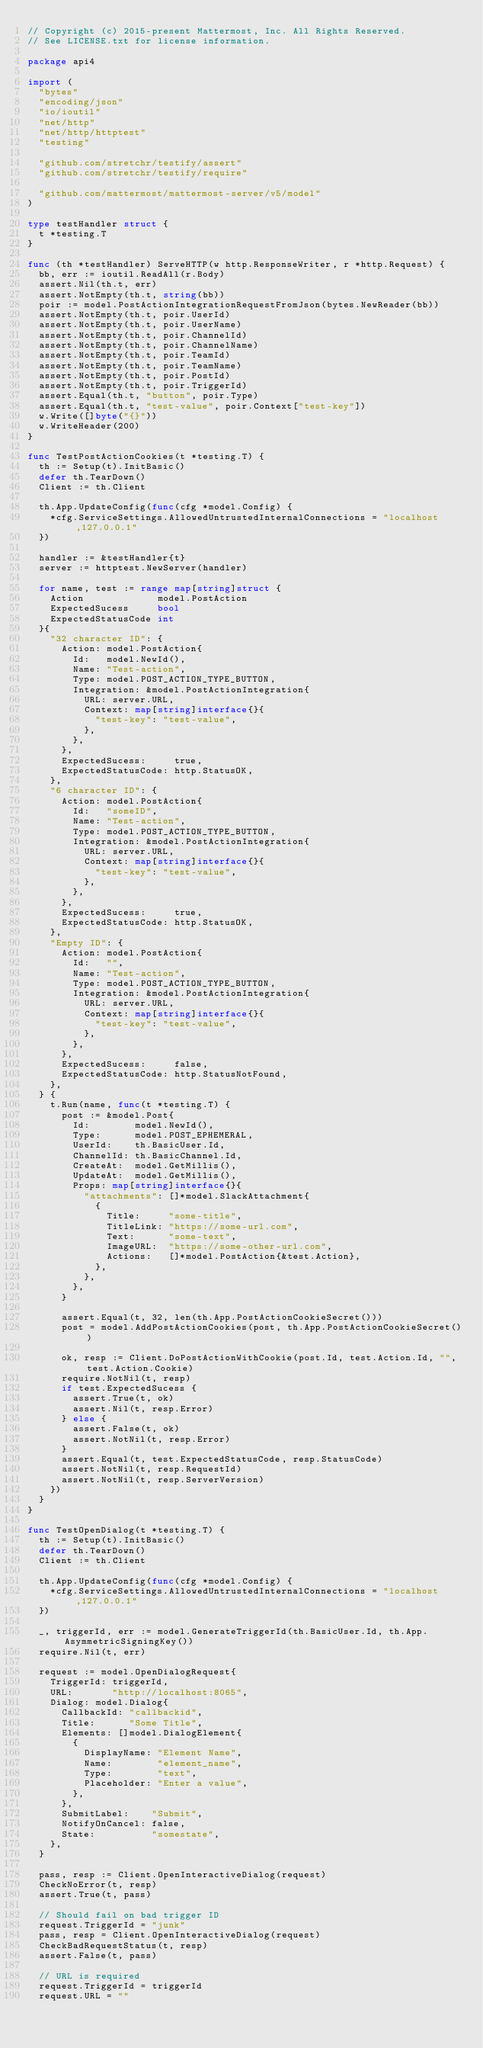Convert code to text. <code><loc_0><loc_0><loc_500><loc_500><_Go_>// Copyright (c) 2015-present Mattermost, Inc. All Rights Reserved.
// See LICENSE.txt for license information.

package api4

import (
	"bytes"
	"encoding/json"
	"io/ioutil"
	"net/http"
	"net/http/httptest"
	"testing"

	"github.com/stretchr/testify/assert"
	"github.com/stretchr/testify/require"

	"github.com/mattermost/mattermost-server/v5/model"
)

type testHandler struct {
	t *testing.T
}

func (th *testHandler) ServeHTTP(w http.ResponseWriter, r *http.Request) {
	bb, err := ioutil.ReadAll(r.Body)
	assert.Nil(th.t, err)
	assert.NotEmpty(th.t, string(bb))
	poir := model.PostActionIntegrationRequestFromJson(bytes.NewReader(bb))
	assert.NotEmpty(th.t, poir.UserId)
	assert.NotEmpty(th.t, poir.UserName)
	assert.NotEmpty(th.t, poir.ChannelId)
	assert.NotEmpty(th.t, poir.ChannelName)
	assert.NotEmpty(th.t, poir.TeamId)
	assert.NotEmpty(th.t, poir.TeamName)
	assert.NotEmpty(th.t, poir.PostId)
	assert.NotEmpty(th.t, poir.TriggerId)
	assert.Equal(th.t, "button", poir.Type)
	assert.Equal(th.t, "test-value", poir.Context["test-key"])
	w.Write([]byte("{}"))
	w.WriteHeader(200)
}

func TestPostActionCookies(t *testing.T) {
	th := Setup(t).InitBasic()
	defer th.TearDown()
	Client := th.Client

	th.App.UpdateConfig(func(cfg *model.Config) {
		*cfg.ServiceSettings.AllowedUntrustedInternalConnections = "localhost,127.0.0.1"
	})

	handler := &testHandler{t}
	server := httptest.NewServer(handler)

	for name, test := range map[string]struct {
		Action             model.PostAction
		ExpectedSucess     bool
		ExpectedStatusCode int
	}{
		"32 character ID": {
			Action: model.PostAction{
				Id:   model.NewId(),
				Name: "Test-action",
				Type: model.POST_ACTION_TYPE_BUTTON,
				Integration: &model.PostActionIntegration{
					URL: server.URL,
					Context: map[string]interface{}{
						"test-key": "test-value",
					},
				},
			},
			ExpectedSucess:     true,
			ExpectedStatusCode: http.StatusOK,
		},
		"6 character ID": {
			Action: model.PostAction{
				Id:   "someID",
				Name: "Test-action",
				Type: model.POST_ACTION_TYPE_BUTTON,
				Integration: &model.PostActionIntegration{
					URL: server.URL,
					Context: map[string]interface{}{
						"test-key": "test-value",
					},
				},
			},
			ExpectedSucess:     true,
			ExpectedStatusCode: http.StatusOK,
		},
		"Empty ID": {
			Action: model.PostAction{
				Id:   "",
				Name: "Test-action",
				Type: model.POST_ACTION_TYPE_BUTTON,
				Integration: &model.PostActionIntegration{
					URL: server.URL,
					Context: map[string]interface{}{
						"test-key": "test-value",
					},
				},
			},
			ExpectedSucess:     false,
			ExpectedStatusCode: http.StatusNotFound,
		},
	} {
		t.Run(name, func(t *testing.T) {
			post := &model.Post{
				Id:        model.NewId(),
				Type:      model.POST_EPHEMERAL,
				UserId:    th.BasicUser.Id,
				ChannelId: th.BasicChannel.Id,
				CreateAt:  model.GetMillis(),
				UpdateAt:  model.GetMillis(),
				Props: map[string]interface{}{
					"attachments": []*model.SlackAttachment{
						{
							Title:     "some-title",
							TitleLink: "https://some-url.com",
							Text:      "some-text",
							ImageURL:  "https://some-other-url.com",
							Actions:   []*model.PostAction{&test.Action},
						},
					},
				},
			}

			assert.Equal(t, 32, len(th.App.PostActionCookieSecret()))
			post = model.AddPostActionCookies(post, th.App.PostActionCookieSecret())

			ok, resp := Client.DoPostActionWithCookie(post.Id, test.Action.Id, "", test.Action.Cookie)
			require.NotNil(t, resp)
			if test.ExpectedSucess {
				assert.True(t, ok)
				assert.Nil(t, resp.Error)
			} else {
				assert.False(t, ok)
				assert.NotNil(t, resp.Error)
			}
			assert.Equal(t, test.ExpectedStatusCode, resp.StatusCode)
			assert.NotNil(t, resp.RequestId)
			assert.NotNil(t, resp.ServerVersion)
		})
	}
}

func TestOpenDialog(t *testing.T) {
	th := Setup(t).InitBasic()
	defer th.TearDown()
	Client := th.Client

	th.App.UpdateConfig(func(cfg *model.Config) {
		*cfg.ServiceSettings.AllowedUntrustedInternalConnections = "localhost,127.0.0.1"
	})

	_, triggerId, err := model.GenerateTriggerId(th.BasicUser.Id, th.App.AsymmetricSigningKey())
	require.Nil(t, err)

	request := model.OpenDialogRequest{
		TriggerId: triggerId,
		URL:       "http://localhost:8065",
		Dialog: model.Dialog{
			CallbackId: "callbackid",
			Title:      "Some Title",
			Elements: []model.DialogElement{
				{
					DisplayName: "Element Name",
					Name:        "element_name",
					Type:        "text",
					Placeholder: "Enter a value",
				},
			},
			SubmitLabel:    "Submit",
			NotifyOnCancel: false,
			State:          "somestate",
		},
	}

	pass, resp := Client.OpenInteractiveDialog(request)
	CheckNoError(t, resp)
	assert.True(t, pass)

	// Should fail on bad trigger ID
	request.TriggerId = "junk"
	pass, resp = Client.OpenInteractiveDialog(request)
	CheckBadRequestStatus(t, resp)
	assert.False(t, pass)

	// URL is required
	request.TriggerId = triggerId
	request.URL = ""</code> 